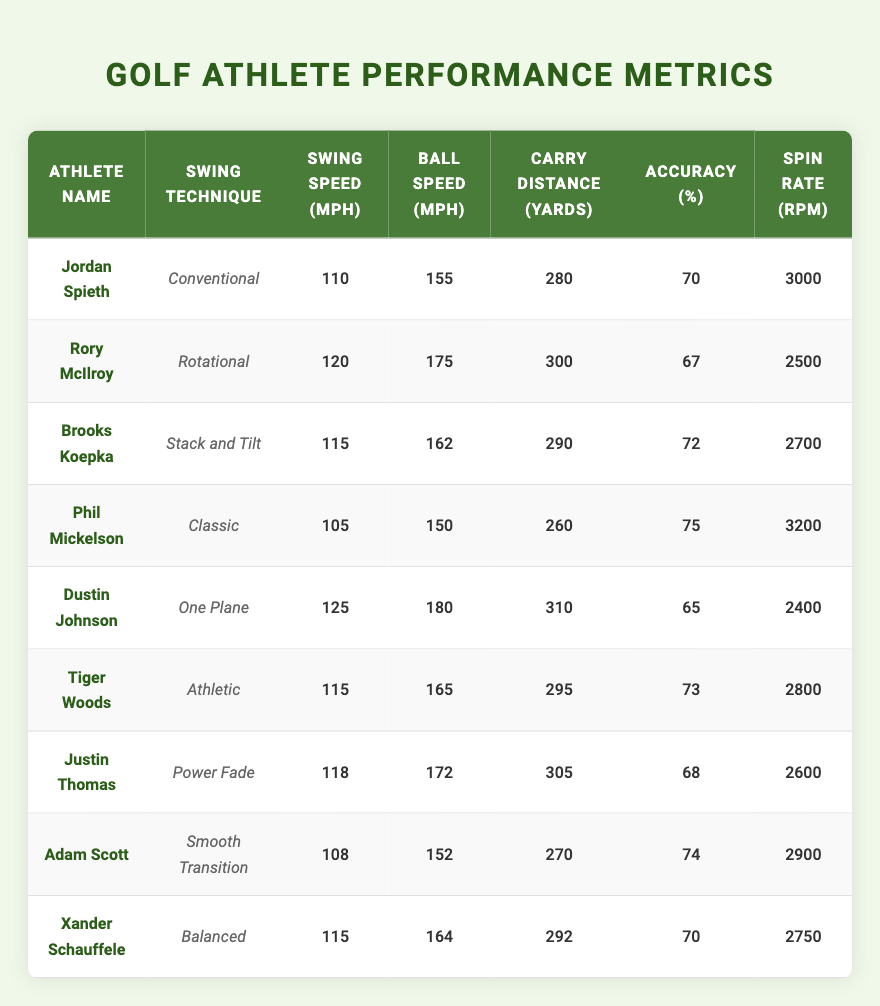What is the swing speed of Rory McIlroy? Looking at the row for Rory McIlroy in the table, the swing speed is listed as 120 mph.
Answer: 120 mph Which athlete has the highest carry distance? By comparing the carry distances listed, Dustin Johnson has the highest distance at 310 yards.
Answer: 310 yards Is Phil Mickelson's accuracy greater than 70%? Phil Mickelson's accuracy is listed as 75%, which is greater than 70%.
Answer: Yes What is the average spin rate of athletes using the "Rotational" swing technique? Rory McIlroy has a spin rate of 2500 rpm. Since only one athlete (Rory McIlroy) uses this technique, the average is also 2500 rpm.
Answer: 2500 rpm Which athlete has the lowest ball speed? Comparing the ball speeds, Phil Mickelson has the lowest at 150 mph.
Answer: 150 mph How much more does Dustin Johnson's swing speed exceed that of Jordan Spieth? Dustin Johnson has a swing speed of 125 mph and Jordan Spieth has 110 mph. The difference is 125 - 110 = 15 mph.
Answer: 15 mph Is the spin rate for Tiger Woods greater than that for Justin Thomas? Tiger Woods has a spin rate of 2800 rpm and Justin Thomas has 2600 rpm. Since 2800 rpm is greater than 2600 rpm, the statement is true.
Answer: Yes What is the combined carry distance of all athletes using the "Conventional" and "Classic" swing techniques? Jordan Spieth (280 yards) and Phil Mickelson (260 yards) are the only athletes in these swing techniques. The sum is 280 + 260 = 540 yards.
Answer: 540 yards Which swing technique corresponds to the athlete with the second-highest accuracy? The second-highest accuracy belongs to Brooks Koepka at 72%, whose technique is "Stack and Tilt".
Answer: Stack and Tilt What is the difference in ball speed between the athletes with the highest and lowest swing speeds? The highest swing speed is from Dustin Johnson at 125 mph and the lowest from Phil Mickelson at 105 mph. The difference in ball speed is 125 - 105 = 20 mph.
Answer: 20 mph 